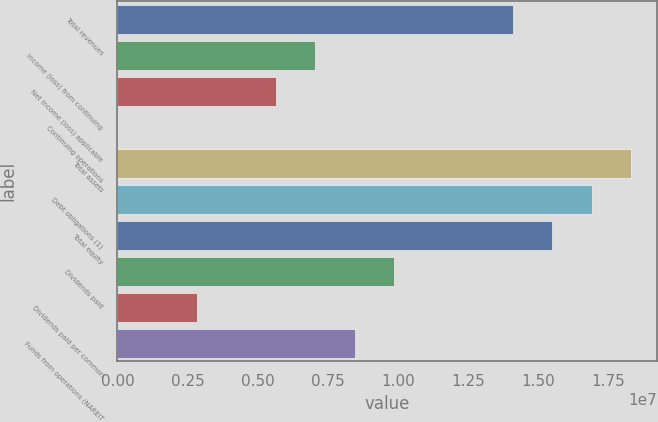Convert chart to OTSL. <chart><loc_0><loc_0><loc_500><loc_500><bar_chart><fcel>Total revenues<fcel>Income (loss) from continuing<fcel>Net income (loss) applicable<fcel>Continuing operations<fcel>Total assets<fcel>Debt obligations (1)<fcel>Total equity<fcel>Dividends paid<fcel>Dividends paid per common<fcel>Funds from operations (NAREIT<nl><fcel>1.40885e+07<fcel>7.04423e+06<fcel>5.63538e+06<fcel>0.88<fcel>1.8315e+07<fcel>1.69062e+07<fcel>1.54973e+07<fcel>9.86192e+06<fcel>2.81769e+06<fcel>8.45308e+06<nl></chart> 